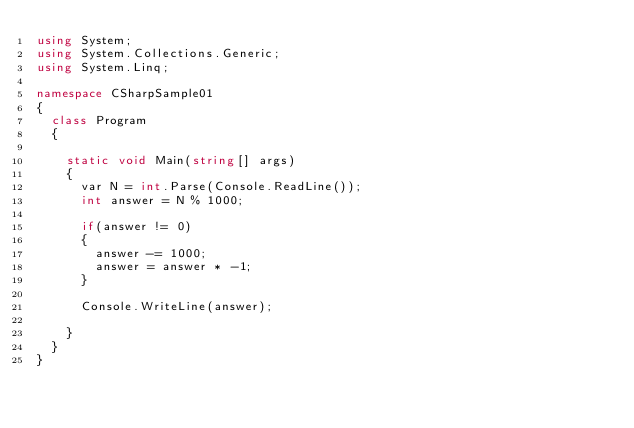Convert code to text. <code><loc_0><loc_0><loc_500><loc_500><_C#_>using System;
using System.Collections.Generic;
using System.Linq;

namespace CSharpSample01
{
	class Program
	{

		static void Main(string[] args)
		{
			var N = int.Parse(Console.ReadLine());
			int answer = N % 1000;

			if(answer != 0)
			{
				answer -= 1000;
				answer = answer * -1;
			}

			Console.WriteLine(answer);

		}
	}
}</code> 